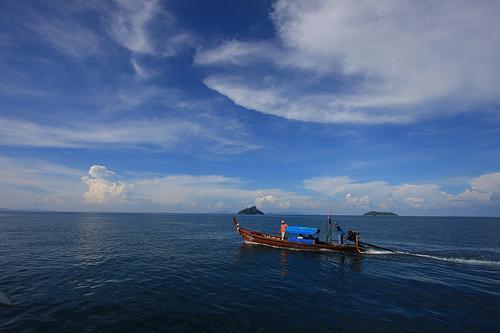How many people are pictured?
Give a very brief answer. 2. 